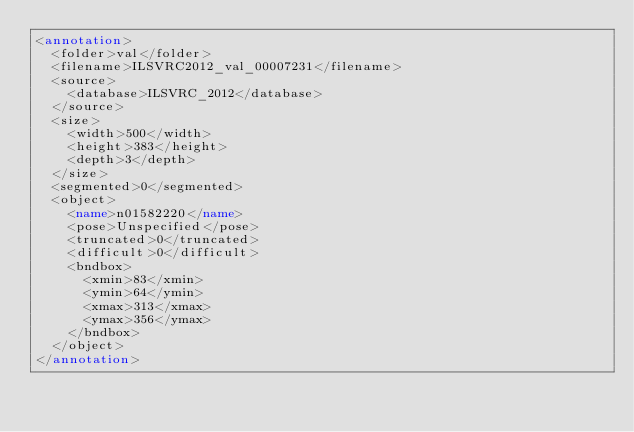<code> <loc_0><loc_0><loc_500><loc_500><_XML_><annotation>
	<folder>val</folder>
	<filename>ILSVRC2012_val_00007231</filename>
	<source>
		<database>ILSVRC_2012</database>
	</source>
	<size>
		<width>500</width>
		<height>383</height>
		<depth>3</depth>
	</size>
	<segmented>0</segmented>
	<object>
		<name>n01582220</name>
		<pose>Unspecified</pose>
		<truncated>0</truncated>
		<difficult>0</difficult>
		<bndbox>
			<xmin>83</xmin>
			<ymin>64</ymin>
			<xmax>313</xmax>
			<ymax>356</ymax>
		</bndbox>
	</object>
</annotation></code> 